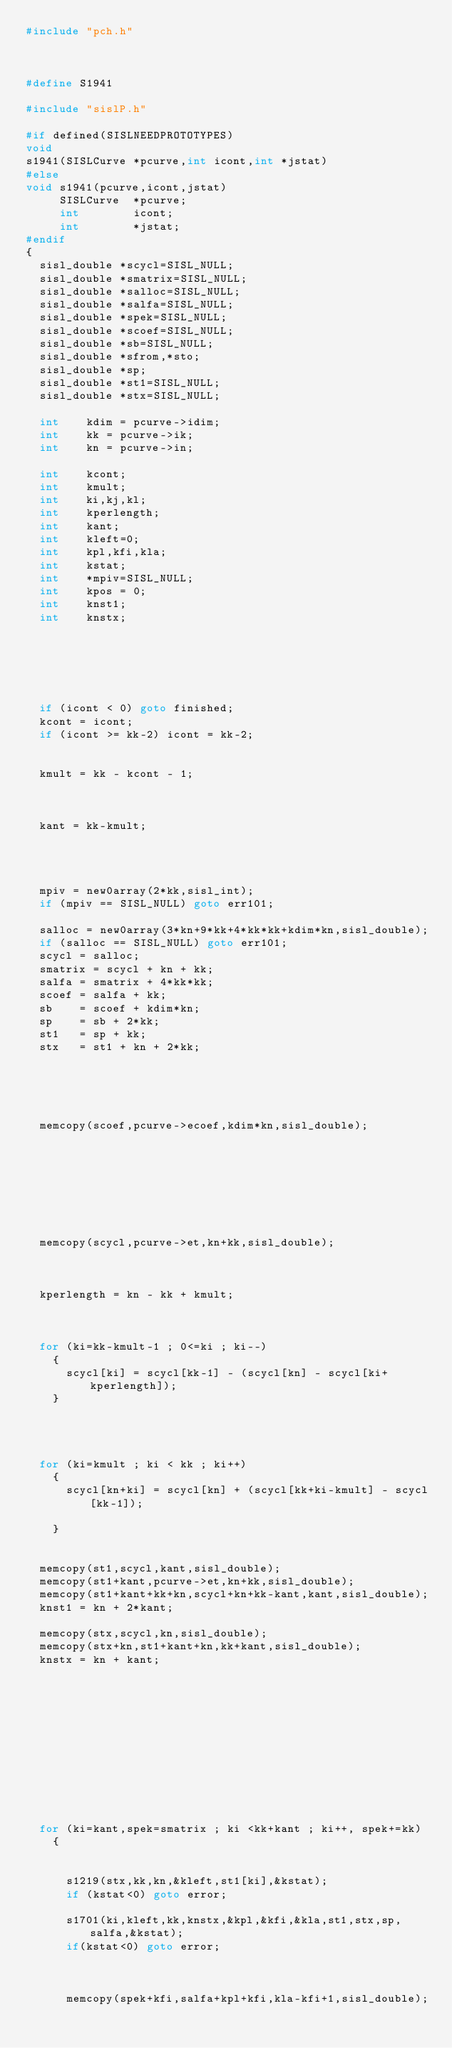<code> <loc_0><loc_0><loc_500><loc_500><_C++_>#include "pch.h"



#define S1941

#include "sislP.h"
 
#if defined(SISLNEEDPROTOTYPES)
void
s1941(SISLCurve *pcurve,int icont,int *jstat)
#else
void s1941(pcurve,icont,jstat)
     SISLCurve  *pcurve;
     int        icont;
     int    	*jstat;
#endif
{
  sisl_double *scycl=SISL_NULL;                    
  sisl_double *smatrix=SISL_NULL;                   
  sisl_double *salloc=SISL_NULL;                    
  sisl_double *salfa=SISL_NULL;                     
  sisl_double *spek=SISL_NULL;                      
  sisl_double *scoef=SISL_NULL;                     
  sisl_double *sb=SISL_NULL;                        
  sisl_double *sfrom,*sto;
  sisl_double *sp;                             
  sisl_double *st1=SISL_NULL;                       
  sisl_double *stx=SISL_NULL;                       

  int    kdim = pcurve->idim;
  int    kk = pcurve->ik;
  int    kn = pcurve->in;

  int    kcont;                           
  int    kmult;                           
  int    ki,kj,kl;
  int    kperlength;
  int    kant;
  int    kleft=0;                         
  int    kpl,kfi,kla;                     
  int    kstat;
  int    *mpiv=SISL_NULL;                      
  int    kpos = 0;
  int    knst1;                           
  int    knstx;                           




  

  if (icont < 0) goto finished;
  kcont = icont;
  if (icont >= kk-2) icont = kk-2;

  
  kmult = kk - kcont - 1;

  

  kant = kk-kmult;


  

  mpiv = new0array(2*kk,sisl_int);
  if (mpiv == SISL_NULL) goto err101;

  salloc = new0array(3*kn+9*kk+4*kk*kk+kdim*kn,sisl_double);
  if (salloc == SISL_NULL) goto err101;
  scycl = salloc;                  
  smatrix = scycl + kn + kk;  
  salfa = smatrix + 4*kk*kk;     
  scoef = salfa + kk;           
  sb    = scoef + kdim*kn;    
  sp    = sb + 2*kk;              
  st1   = sp + kk;                
  stx   = st1 + kn + 2*kk;       



  

  memcopy(scoef,pcurve->ecoef,kdim*kn,sisl_double);



  


  

  memcopy(scycl,pcurve->et,kn+kk,sisl_double);

  

  kperlength = kn - kk + kmult;

  

  for (ki=kk-kmult-1 ; 0<=ki ; ki--)
    {
      scycl[ki] = scycl[kk-1] - (scycl[kn] - scycl[ki+kperlength]);
    }


  

  for (ki=kmult ; ki < kk ; ki++)
    {
      scycl[kn+ki] = scycl[kn] + (scycl[kk+ki-kmult] - scycl[kk-1]);

    }
      

  memcopy(st1,scycl,kant,sisl_double);
  memcopy(st1+kant,pcurve->et,kn+kk,sisl_double);
  memcopy(st1+kant+kk+kn,scycl+kn+kk-kant,kant,sisl_double);
  knst1 = kn + 2*kant;

  memcopy(stx,scycl,kn,sisl_double);
  memcopy(stx+kn,st1+kant+kn,kk+kant,sisl_double);
  knstx = kn + kant;

  


  


  


  

  for (ki=kant,spek=smatrix ; ki <kk+kant ; ki++, spek+=kk)
    {
      

      s1219(stx,kk,kn,&kleft,st1[ki],&kstat);
      if (kstat<0) goto error;

      s1701(ki,kleft,kk,knstx,&kpl,&kfi,&kla,st1,stx,sp,salfa,&kstat);
      if(kstat<0) goto error;

      

      memcopy(spek+kfi,salfa+kpl+kfi,kla-kfi+1,sisl_double);</code> 